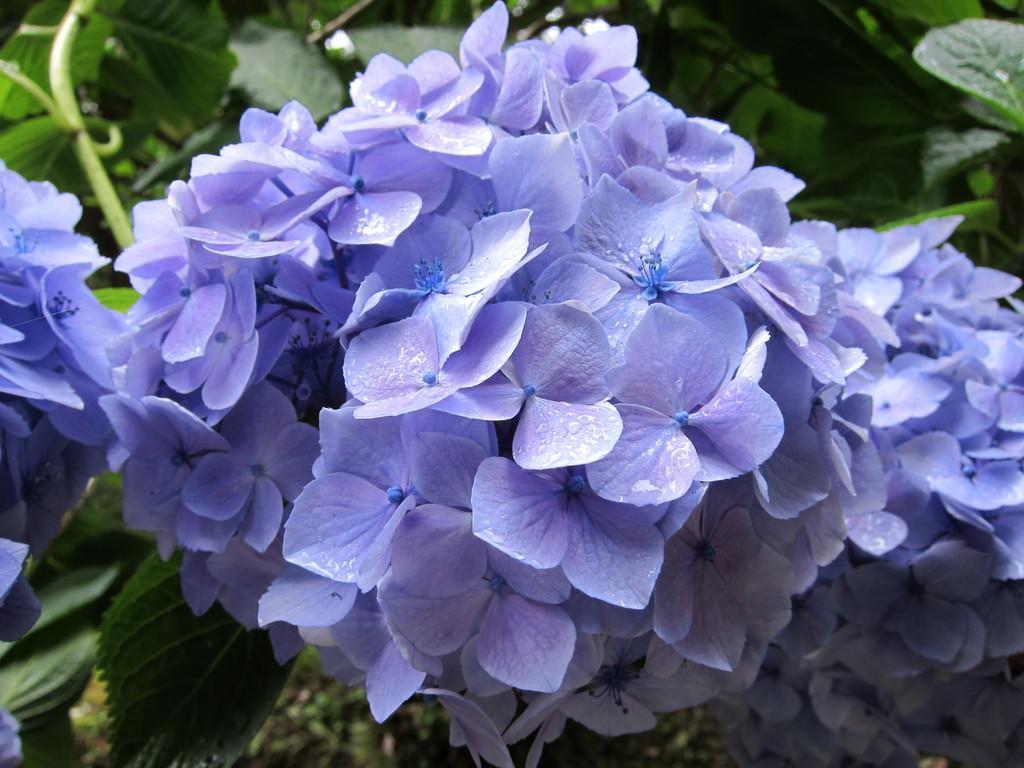Could you give a brief overview of what you see in this image? In this image we can see the flowers, leaves. And we can see the plants. 